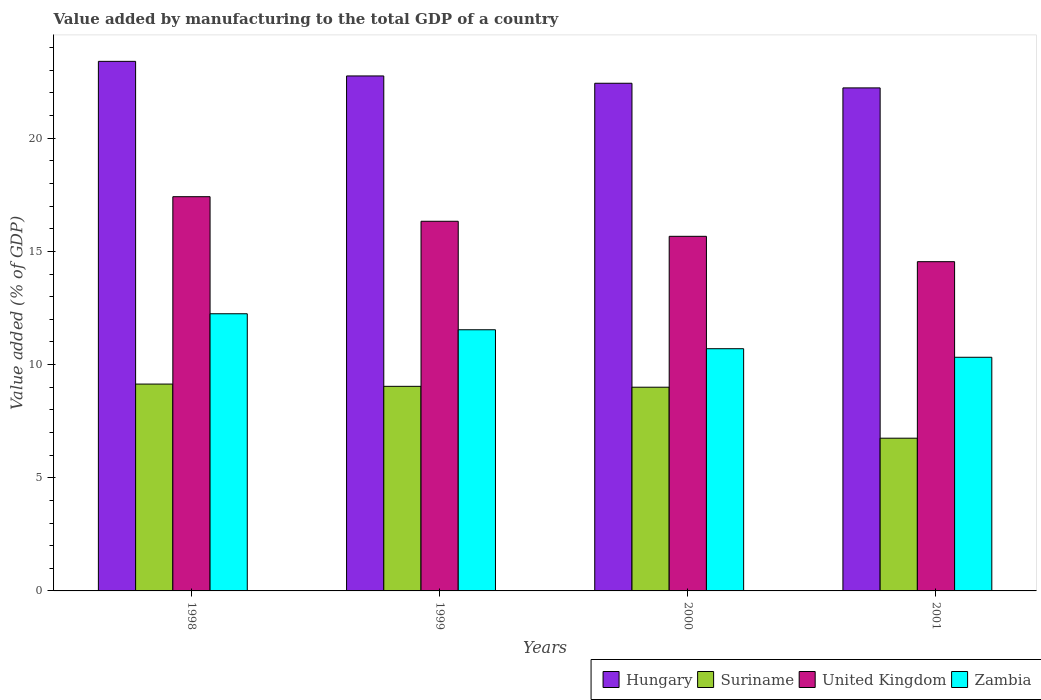How many different coloured bars are there?
Provide a succinct answer. 4. Are the number of bars per tick equal to the number of legend labels?
Your response must be concise. Yes. Are the number of bars on each tick of the X-axis equal?
Ensure brevity in your answer.  Yes. How many bars are there on the 2nd tick from the left?
Ensure brevity in your answer.  4. How many bars are there on the 4th tick from the right?
Provide a succinct answer. 4. What is the label of the 2nd group of bars from the left?
Keep it short and to the point. 1999. What is the value added by manufacturing to the total GDP in United Kingdom in 1999?
Ensure brevity in your answer.  16.33. Across all years, what is the maximum value added by manufacturing to the total GDP in Hungary?
Your answer should be compact. 23.39. Across all years, what is the minimum value added by manufacturing to the total GDP in Hungary?
Ensure brevity in your answer.  22.22. In which year was the value added by manufacturing to the total GDP in Zambia maximum?
Make the answer very short. 1998. In which year was the value added by manufacturing to the total GDP in Suriname minimum?
Ensure brevity in your answer.  2001. What is the total value added by manufacturing to the total GDP in Suriname in the graph?
Your response must be concise. 33.92. What is the difference between the value added by manufacturing to the total GDP in United Kingdom in 1998 and that in 1999?
Give a very brief answer. 1.09. What is the difference between the value added by manufacturing to the total GDP in United Kingdom in 2000 and the value added by manufacturing to the total GDP in Zambia in 2001?
Make the answer very short. 5.34. What is the average value added by manufacturing to the total GDP in Hungary per year?
Keep it short and to the point. 22.7. In the year 1998, what is the difference between the value added by manufacturing to the total GDP in Suriname and value added by manufacturing to the total GDP in Zambia?
Your answer should be very brief. -3.11. In how many years, is the value added by manufacturing to the total GDP in Hungary greater than 10 %?
Offer a terse response. 4. What is the ratio of the value added by manufacturing to the total GDP in United Kingdom in 2000 to that in 2001?
Make the answer very short. 1.08. Is the difference between the value added by manufacturing to the total GDP in Suriname in 1999 and 2001 greater than the difference between the value added by manufacturing to the total GDP in Zambia in 1999 and 2001?
Offer a terse response. Yes. What is the difference between the highest and the second highest value added by manufacturing to the total GDP in Zambia?
Your answer should be compact. 0.71. What is the difference between the highest and the lowest value added by manufacturing to the total GDP in Zambia?
Ensure brevity in your answer.  1.92. In how many years, is the value added by manufacturing to the total GDP in Zambia greater than the average value added by manufacturing to the total GDP in Zambia taken over all years?
Provide a succinct answer. 2. What does the 4th bar from the left in 2001 represents?
Your answer should be compact. Zambia. What does the 4th bar from the right in 1998 represents?
Ensure brevity in your answer.  Hungary. Are all the bars in the graph horizontal?
Provide a succinct answer. No. How many years are there in the graph?
Offer a terse response. 4. Are the values on the major ticks of Y-axis written in scientific E-notation?
Offer a very short reply. No. Does the graph contain grids?
Provide a short and direct response. No. How are the legend labels stacked?
Provide a succinct answer. Horizontal. What is the title of the graph?
Offer a very short reply. Value added by manufacturing to the total GDP of a country. What is the label or title of the Y-axis?
Provide a short and direct response. Value added (% of GDP). What is the Value added (% of GDP) of Hungary in 1998?
Give a very brief answer. 23.39. What is the Value added (% of GDP) in Suriname in 1998?
Your answer should be compact. 9.14. What is the Value added (% of GDP) in United Kingdom in 1998?
Make the answer very short. 17.41. What is the Value added (% of GDP) in Zambia in 1998?
Your answer should be compact. 12.24. What is the Value added (% of GDP) of Hungary in 1999?
Make the answer very short. 22.75. What is the Value added (% of GDP) in Suriname in 1999?
Offer a very short reply. 9.04. What is the Value added (% of GDP) of United Kingdom in 1999?
Offer a very short reply. 16.33. What is the Value added (% of GDP) in Zambia in 1999?
Provide a short and direct response. 11.54. What is the Value added (% of GDP) of Hungary in 2000?
Offer a very short reply. 22.43. What is the Value added (% of GDP) of Suriname in 2000?
Ensure brevity in your answer.  9. What is the Value added (% of GDP) of United Kingdom in 2000?
Ensure brevity in your answer.  15.66. What is the Value added (% of GDP) of Zambia in 2000?
Offer a terse response. 10.7. What is the Value added (% of GDP) in Hungary in 2001?
Provide a short and direct response. 22.22. What is the Value added (% of GDP) in Suriname in 2001?
Your answer should be compact. 6.75. What is the Value added (% of GDP) in United Kingdom in 2001?
Offer a very short reply. 14.54. What is the Value added (% of GDP) of Zambia in 2001?
Offer a terse response. 10.32. Across all years, what is the maximum Value added (% of GDP) in Hungary?
Your answer should be very brief. 23.39. Across all years, what is the maximum Value added (% of GDP) in Suriname?
Offer a very short reply. 9.14. Across all years, what is the maximum Value added (% of GDP) of United Kingdom?
Make the answer very short. 17.41. Across all years, what is the maximum Value added (% of GDP) in Zambia?
Make the answer very short. 12.24. Across all years, what is the minimum Value added (% of GDP) of Hungary?
Offer a very short reply. 22.22. Across all years, what is the minimum Value added (% of GDP) of Suriname?
Provide a short and direct response. 6.75. Across all years, what is the minimum Value added (% of GDP) in United Kingdom?
Your answer should be very brief. 14.54. Across all years, what is the minimum Value added (% of GDP) in Zambia?
Offer a very short reply. 10.32. What is the total Value added (% of GDP) in Hungary in the graph?
Offer a terse response. 90.79. What is the total Value added (% of GDP) in Suriname in the graph?
Your response must be concise. 33.92. What is the total Value added (% of GDP) of United Kingdom in the graph?
Make the answer very short. 63.95. What is the total Value added (% of GDP) in Zambia in the graph?
Your answer should be very brief. 44.8. What is the difference between the Value added (% of GDP) in Hungary in 1998 and that in 1999?
Provide a short and direct response. 0.64. What is the difference between the Value added (% of GDP) in Suriname in 1998 and that in 1999?
Ensure brevity in your answer.  0.1. What is the difference between the Value added (% of GDP) in United Kingdom in 1998 and that in 1999?
Make the answer very short. 1.09. What is the difference between the Value added (% of GDP) of Zambia in 1998 and that in 1999?
Offer a terse response. 0.71. What is the difference between the Value added (% of GDP) of Hungary in 1998 and that in 2000?
Provide a short and direct response. 0.97. What is the difference between the Value added (% of GDP) of Suriname in 1998 and that in 2000?
Provide a succinct answer. 0.14. What is the difference between the Value added (% of GDP) in United Kingdom in 1998 and that in 2000?
Make the answer very short. 1.75. What is the difference between the Value added (% of GDP) in Zambia in 1998 and that in 2000?
Give a very brief answer. 1.54. What is the difference between the Value added (% of GDP) in Hungary in 1998 and that in 2001?
Your answer should be compact. 1.17. What is the difference between the Value added (% of GDP) in Suriname in 1998 and that in 2001?
Your answer should be very brief. 2.39. What is the difference between the Value added (% of GDP) in United Kingdom in 1998 and that in 2001?
Your response must be concise. 2.87. What is the difference between the Value added (% of GDP) in Zambia in 1998 and that in 2001?
Keep it short and to the point. 1.92. What is the difference between the Value added (% of GDP) in Hungary in 1999 and that in 2000?
Provide a short and direct response. 0.32. What is the difference between the Value added (% of GDP) of Suriname in 1999 and that in 2000?
Keep it short and to the point. 0.04. What is the difference between the Value added (% of GDP) of United Kingdom in 1999 and that in 2000?
Keep it short and to the point. 0.66. What is the difference between the Value added (% of GDP) in Zambia in 1999 and that in 2000?
Provide a succinct answer. 0.84. What is the difference between the Value added (% of GDP) of Hungary in 1999 and that in 2001?
Give a very brief answer. 0.53. What is the difference between the Value added (% of GDP) in Suriname in 1999 and that in 2001?
Keep it short and to the point. 2.29. What is the difference between the Value added (% of GDP) of United Kingdom in 1999 and that in 2001?
Your response must be concise. 1.78. What is the difference between the Value added (% of GDP) in Zambia in 1999 and that in 2001?
Your answer should be compact. 1.21. What is the difference between the Value added (% of GDP) in Hungary in 2000 and that in 2001?
Provide a short and direct response. 0.2. What is the difference between the Value added (% of GDP) in Suriname in 2000 and that in 2001?
Offer a terse response. 2.25. What is the difference between the Value added (% of GDP) of United Kingdom in 2000 and that in 2001?
Ensure brevity in your answer.  1.12. What is the difference between the Value added (% of GDP) of Zambia in 2000 and that in 2001?
Ensure brevity in your answer.  0.38. What is the difference between the Value added (% of GDP) of Hungary in 1998 and the Value added (% of GDP) of Suriname in 1999?
Provide a succinct answer. 14.36. What is the difference between the Value added (% of GDP) of Hungary in 1998 and the Value added (% of GDP) of United Kingdom in 1999?
Give a very brief answer. 7.06. What is the difference between the Value added (% of GDP) in Hungary in 1998 and the Value added (% of GDP) in Zambia in 1999?
Your answer should be very brief. 11.86. What is the difference between the Value added (% of GDP) in Suriname in 1998 and the Value added (% of GDP) in United Kingdom in 1999?
Keep it short and to the point. -7.19. What is the difference between the Value added (% of GDP) of Suriname in 1998 and the Value added (% of GDP) of Zambia in 1999?
Offer a terse response. -2.4. What is the difference between the Value added (% of GDP) of United Kingdom in 1998 and the Value added (% of GDP) of Zambia in 1999?
Provide a succinct answer. 5.88. What is the difference between the Value added (% of GDP) in Hungary in 1998 and the Value added (% of GDP) in Suriname in 2000?
Offer a very short reply. 14.39. What is the difference between the Value added (% of GDP) of Hungary in 1998 and the Value added (% of GDP) of United Kingdom in 2000?
Keep it short and to the point. 7.73. What is the difference between the Value added (% of GDP) of Hungary in 1998 and the Value added (% of GDP) of Zambia in 2000?
Provide a short and direct response. 12.69. What is the difference between the Value added (% of GDP) of Suriname in 1998 and the Value added (% of GDP) of United Kingdom in 2000?
Keep it short and to the point. -6.53. What is the difference between the Value added (% of GDP) in Suriname in 1998 and the Value added (% of GDP) in Zambia in 2000?
Provide a succinct answer. -1.56. What is the difference between the Value added (% of GDP) of United Kingdom in 1998 and the Value added (% of GDP) of Zambia in 2000?
Make the answer very short. 6.72. What is the difference between the Value added (% of GDP) of Hungary in 1998 and the Value added (% of GDP) of Suriname in 2001?
Your response must be concise. 16.65. What is the difference between the Value added (% of GDP) of Hungary in 1998 and the Value added (% of GDP) of United Kingdom in 2001?
Offer a terse response. 8.85. What is the difference between the Value added (% of GDP) of Hungary in 1998 and the Value added (% of GDP) of Zambia in 2001?
Ensure brevity in your answer.  13.07. What is the difference between the Value added (% of GDP) in Suriname in 1998 and the Value added (% of GDP) in United Kingdom in 2001?
Your response must be concise. -5.41. What is the difference between the Value added (% of GDP) in Suriname in 1998 and the Value added (% of GDP) in Zambia in 2001?
Offer a terse response. -1.18. What is the difference between the Value added (% of GDP) in United Kingdom in 1998 and the Value added (% of GDP) in Zambia in 2001?
Your answer should be compact. 7.09. What is the difference between the Value added (% of GDP) in Hungary in 1999 and the Value added (% of GDP) in Suriname in 2000?
Give a very brief answer. 13.75. What is the difference between the Value added (% of GDP) in Hungary in 1999 and the Value added (% of GDP) in United Kingdom in 2000?
Provide a short and direct response. 7.08. What is the difference between the Value added (% of GDP) in Hungary in 1999 and the Value added (% of GDP) in Zambia in 2000?
Provide a succinct answer. 12.05. What is the difference between the Value added (% of GDP) in Suriname in 1999 and the Value added (% of GDP) in United Kingdom in 2000?
Keep it short and to the point. -6.63. What is the difference between the Value added (% of GDP) in Suriname in 1999 and the Value added (% of GDP) in Zambia in 2000?
Offer a terse response. -1.66. What is the difference between the Value added (% of GDP) of United Kingdom in 1999 and the Value added (% of GDP) of Zambia in 2000?
Keep it short and to the point. 5.63. What is the difference between the Value added (% of GDP) of Hungary in 1999 and the Value added (% of GDP) of Suriname in 2001?
Make the answer very short. 16. What is the difference between the Value added (% of GDP) of Hungary in 1999 and the Value added (% of GDP) of United Kingdom in 2001?
Provide a short and direct response. 8.2. What is the difference between the Value added (% of GDP) of Hungary in 1999 and the Value added (% of GDP) of Zambia in 2001?
Keep it short and to the point. 12.43. What is the difference between the Value added (% of GDP) of Suriname in 1999 and the Value added (% of GDP) of United Kingdom in 2001?
Your response must be concise. -5.51. What is the difference between the Value added (% of GDP) in Suriname in 1999 and the Value added (% of GDP) in Zambia in 2001?
Keep it short and to the point. -1.28. What is the difference between the Value added (% of GDP) of United Kingdom in 1999 and the Value added (% of GDP) of Zambia in 2001?
Your answer should be very brief. 6.01. What is the difference between the Value added (% of GDP) in Hungary in 2000 and the Value added (% of GDP) in Suriname in 2001?
Keep it short and to the point. 15.68. What is the difference between the Value added (% of GDP) in Hungary in 2000 and the Value added (% of GDP) in United Kingdom in 2001?
Keep it short and to the point. 7.88. What is the difference between the Value added (% of GDP) of Hungary in 2000 and the Value added (% of GDP) of Zambia in 2001?
Your answer should be very brief. 12.1. What is the difference between the Value added (% of GDP) in Suriname in 2000 and the Value added (% of GDP) in United Kingdom in 2001?
Your answer should be compact. -5.55. What is the difference between the Value added (% of GDP) in Suriname in 2000 and the Value added (% of GDP) in Zambia in 2001?
Offer a terse response. -1.32. What is the difference between the Value added (% of GDP) in United Kingdom in 2000 and the Value added (% of GDP) in Zambia in 2001?
Your response must be concise. 5.34. What is the average Value added (% of GDP) in Hungary per year?
Offer a terse response. 22.7. What is the average Value added (% of GDP) in Suriname per year?
Provide a short and direct response. 8.48. What is the average Value added (% of GDP) of United Kingdom per year?
Ensure brevity in your answer.  15.99. What is the average Value added (% of GDP) in Zambia per year?
Your response must be concise. 11.2. In the year 1998, what is the difference between the Value added (% of GDP) in Hungary and Value added (% of GDP) in Suriname?
Your answer should be compact. 14.26. In the year 1998, what is the difference between the Value added (% of GDP) in Hungary and Value added (% of GDP) in United Kingdom?
Keep it short and to the point. 5.98. In the year 1998, what is the difference between the Value added (% of GDP) in Hungary and Value added (% of GDP) in Zambia?
Provide a short and direct response. 11.15. In the year 1998, what is the difference between the Value added (% of GDP) in Suriname and Value added (% of GDP) in United Kingdom?
Provide a short and direct response. -8.28. In the year 1998, what is the difference between the Value added (% of GDP) in Suriname and Value added (% of GDP) in Zambia?
Make the answer very short. -3.11. In the year 1998, what is the difference between the Value added (% of GDP) of United Kingdom and Value added (% of GDP) of Zambia?
Offer a terse response. 5.17. In the year 1999, what is the difference between the Value added (% of GDP) in Hungary and Value added (% of GDP) in Suriname?
Offer a very short reply. 13.71. In the year 1999, what is the difference between the Value added (% of GDP) of Hungary and Value added (% of GDP) of United Kingdom?
Provide a succinct answer. 6.42. In the year 1999, what is the difference between the Value added (% of GDP) of Hungary and Value added (% of GDP) of Zambia?
Give a very brief answer. 11.21. In the year 1999, what is the difference between the Value added (% of GDP) in Suriname and Value added (% of GDP) in United Kingdom?
Make the answer very short. -7.29. In the year 1999, what is the difference between the Value added (% of GDP) of Suriname and Value added (% of GDP) of Zambia?
Make the answer very short. -2.5. In the year 1999, what is the difference between the Value added (% of GDP) of United Kingdom and Value added (% of GDP) of Zambia?
Your answer should be very brief. 4.79. In the year 2000, what is the difference between the Value added (% of GDP) of Hungary and Value added (% of GDP) of Suriname?
Offer a very short reply. 13.43. In the year 2000, what is the difference between the Value added (% of GDP) in Hungary and Value added (% of GDP) in United Kingdom?
Provide a short and direct response. 6.76. In the year 2000, what is the difference between the Value added (% of GDP) of Hungary and Value added (% of GDP) of Zambia?
Provide a short and direct response. 11.73. In the year 2000, what is the difference between the Value added (% of GDP) of Suriname and Value added (% of GDP) of United Kingdom?
Offer a terse response. -6.67. In the year 2000, what is the difference between the Value added (% of GDP) of Suriname and Value added (% of GDP) of Zambia?
Give a very brief answer. -1.7. In the year 2000, what is the difference between the Value added (% of GDP) in United Kingdom and Value added (% of GDP) in Zambia?
Your response must be concise. 4.97. In the year 2001, what is the difference between the Value added (% of GDP) in Hungary and Value added (% of GDP) in Suriname?
Provide a succinct answer. 15.47. In the year 2001, what is the difference between the Value added (% of GDP) of Hungary and Value added (% of GDP) of United Kingdom?
Offer a terse response. 7.68. In the year 2001, what is the difference between the Value added (% of GDP) in Hungary and Value added (% of GDP) in Zambia?
Offer a terse response. 11.9. In the year 2001, what is the difference between the Value added (% of GDP) in Suriname and Value added (% of GDP) in United Kingdom?
Offer a terse response. -7.8. In the year 2001, what is the difference between the Value added (% of GDP) in Suriname and Value added (% of GDP) in Zambia?
Provide a short and direct response. -3.57. In the year 2001, what is the difference between the Value added (% of GDP) in United Kingdom and Value added (% of GDP) in Zambia?
Offer a very short reply. 4.22. What is the ratio of the Value added (% of GDP) in Hungary in 1998 to that in 1999?
Ensure brevity in your answer.  1.03. What is the ratio of the Value added (% of GDP) of Suriname in 1998 to that in 1999?
Provide a short and direct response. 1.01. What is the ratio of the Value added (% of GDP) of United Kingdom in 1998 to that in 1999?
Provide a short and direct response. 1.07. What is the ratio of the Value added (% of GDP) in Zambia in 1998 to that in 1999?
Make the answer very short. 1.06. What is the ratio of the Value added (% of GDP) in Hungary in 1998 to that in 2000?
Make the answer very short. 1.04. What is the ratio of the Value added (% of GDP) in Suriname in 1998 to that in 2000?
Offer a very short reply. 1.02. What is the ratio of the Value added (% of GDP) of United Kingdom in 1998 to that in 2000?
Keep it short and to the point. 1.11. What is the ratio of the Value added (% of GDP) in Zambia in 1998 to that in 2000?
Provide a short and direct response. 1.14. What is the ratio of the Value added (% of GDP) of Hungary in 1998 to that in 2001?
Give a very brief answer. 1.05. What is the ratio of the Value added (% of GDP) of Suriname in 1998 to that in 2001?
Your response must be concise. 1.35. What is the ratio of the Value added (% of GDP) of United Kingdom in 1998 to that in 2001?
Provide a short and direct response. 1.2. What is the ratio of the Value added (% of GDP) in Zambia in 1998 to that in 2001?
Ensure brevity in your answer.  1.19. What is the ratio of the Value added (% of GDP) in Hungary in 1999 to that in 2000?
Give a very brief answer. 1.01. What is the ratio of the Value added (% of GDP) of Suriname in 1999 to that in 2000?
Provide a short and direct response. 1. What is the ratio of the Value added (% of GDP) of United Kingdom in 1999 to that in 2000?
Give a very brief answer. 1.04. What is the ratio of the Value added (% of GDP) in Zambia in 1999 to that in 2000?
Your response must be concise. 1.08. What is the ratio of the Value added (% of GDP) of Hungary in 1999 to that in 2001?
Provide a short and direct response. 1.02. What is the ratio of the Value added (% of GDP) in Suriname in 1999 to that in 2001?
Your answer should be compact. 1.34. What is the ratio of the Value added (% of GDP) in United Kingdom in 1999 to that in 2001?
Keep it short and to the point. 1.12. What is the ratio of the Value added (% of GDP) in Zambia in 1999 to that in 2001?
Provide a succinct answer. 1.12. What is the ratio of the Value added (% of GDP) in Hungary in 2000 to that in 2001?
Ensure brevity in your answer.  1.01. What is the ratio of the Value added (% of GDP) in Suriname in 2000 to that in 2001?
Provide a short and direct response. 1.33. What is the ratio of the Value added (% of GDP) of United Kingdom in 2000 to that in 2001?
Offer a very short reply. 1.08. What is the ratio of the Value added (% of GDP) of Zambia in 2000 to that in 2001?
Offer a terse response. 1.04. What is the difference between the highest and the second highest Value added (% of GDP) of Hungary?
Your response must be concise. 0.64. What is the difference between the highest and the second highest Value added (% of GDP) in Suriname?
Your response must be concise. 0.1. What is the difference between the highest and the second highest Value added (% of GDP) of United Kingdom?
Your answer should be very brief. 1.09. What is the difference between the highest and the second highest Value added (% of GDP) in Zambia?
Make the answer very short. 0.71. What is the difference between the highest and the lowest Value added (% of GDP) of Hungary?
Provide a short and direct response. 1.17. What is the difference between the highest and the lowest Value added (% of GDP) in Suriname?
Ensure brevity in your answer.  2.39. What is the difference between the highest and the lowest Value added (% of GDP) of United Kingdom?
Offer a very short reply. 2.87. What is the difference between the highest and the lowest Value added (% of GDP) in Zambia?
Your response must be concise. 1.92. 